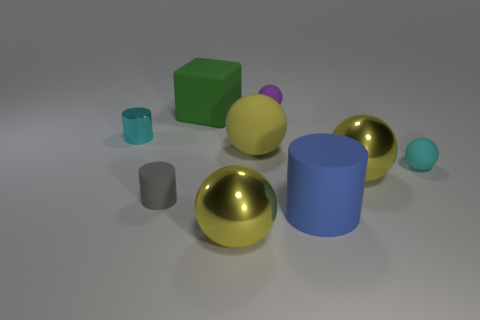There is a large yellow object to the right of the big yellow rubber object to the left of the small purple rubber ball; how many spheres are on the left side of it? To provide a precise count, I'll need to carefully consider the positioning of the objects relative to one another. After examining the image, there are two spheres situated to the left of the large yellow object. One is a larger gold sphere, and the other is a smaller light blue sphere. Therefore, the total number of spheres on the left side of the large yellow object is two. 